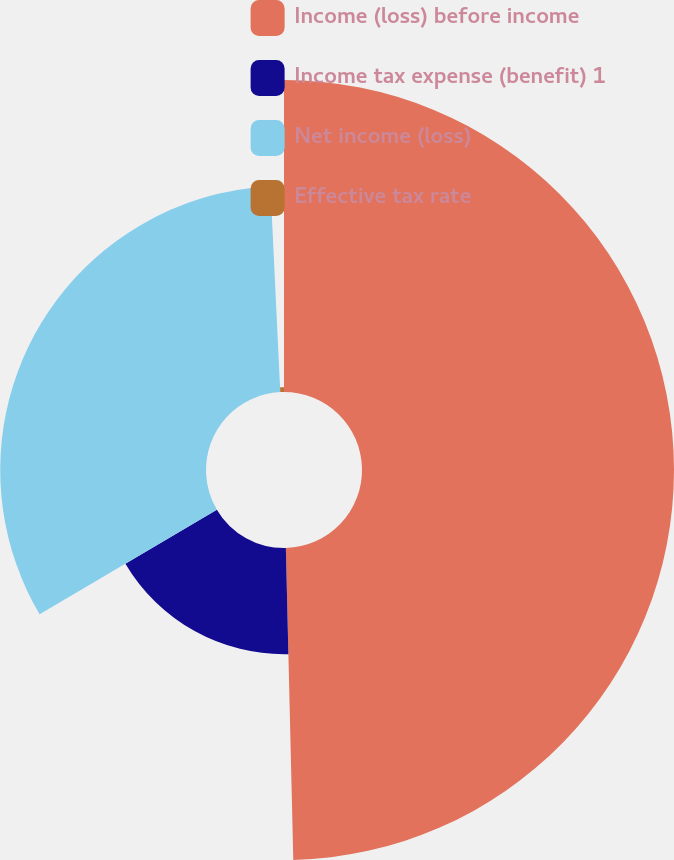Convert chart. <chart><loc_0><loc_0><loc_500><loc_500><pie_chart><fcel>Income (loss) before income<fcel>Income tax expense (benefit) 1<fcel>Net income (loss)<fcel>Effective tax rate<nl><fcel>49.62%<fcel>16.89%<fcel>32.73%<fcel>0.76%<nl></chart> 